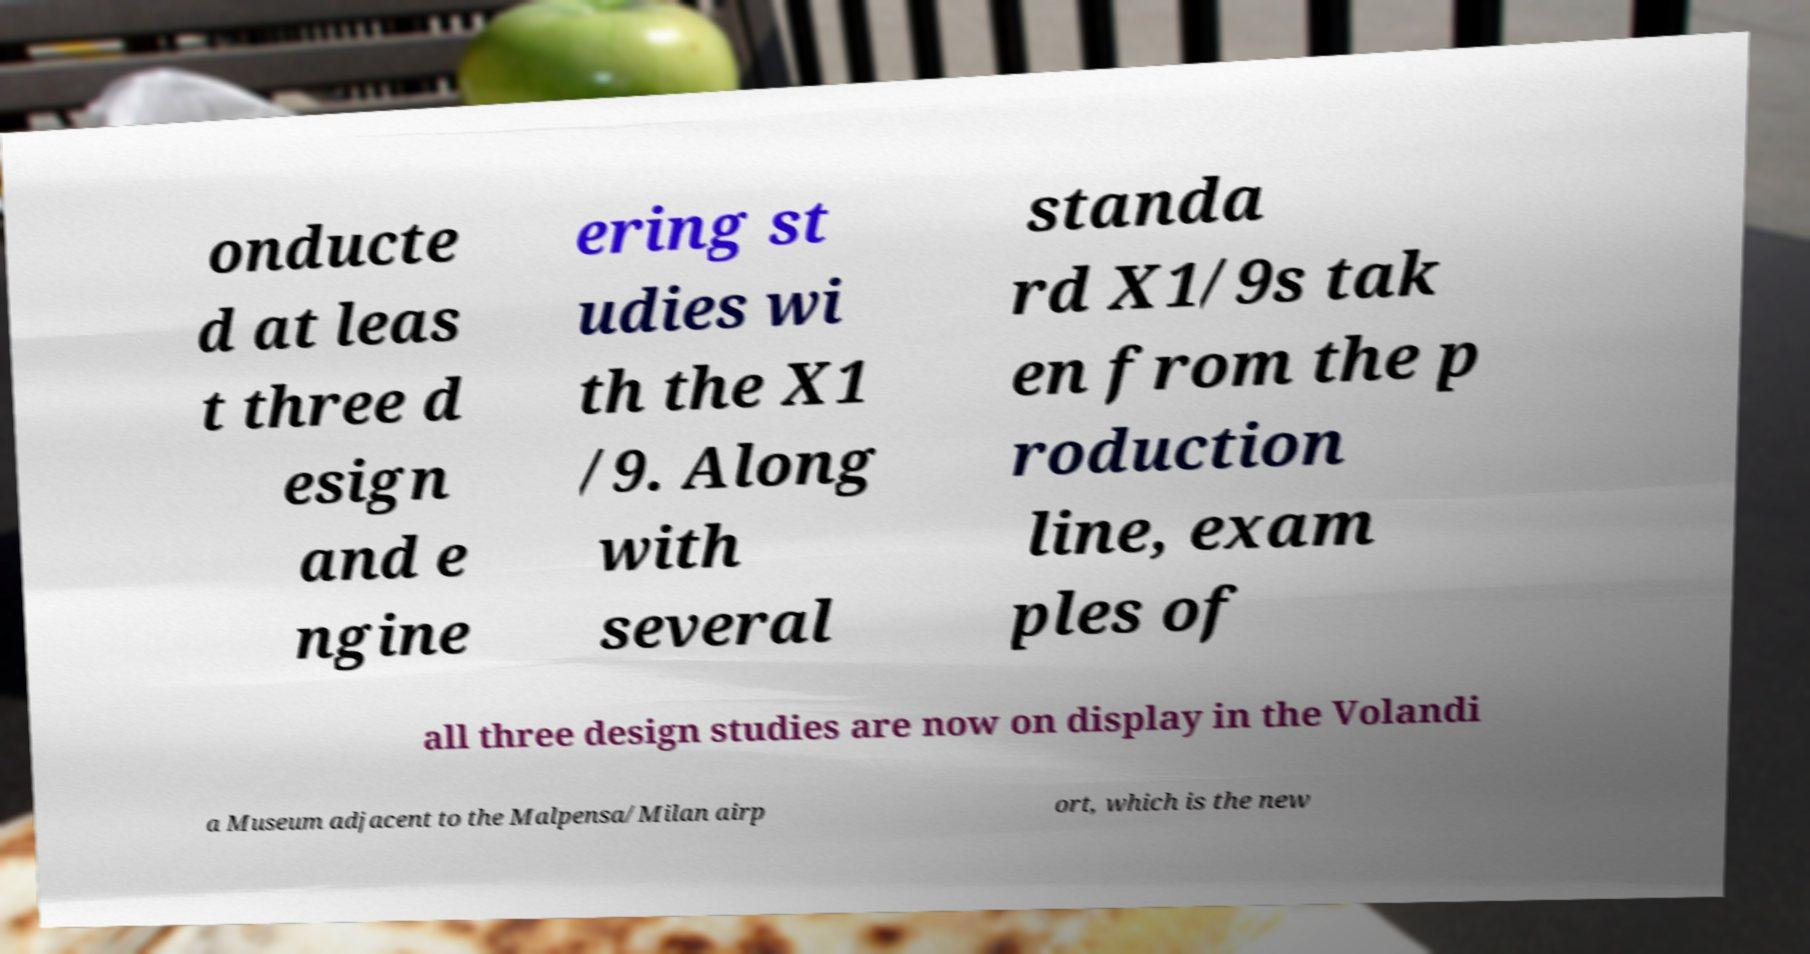I need the written content from this picture converted into text. Can you do that? onducte d at leas t three d esign and e ngine ering st udies wi th the X1 /9. Along with several standa rd X1/9s tak en from the p roduction line, exam ples of all three design studies are now on display in the Volandi a Museum adjacent to the Malpensa/Milan airp ort, which is the new 